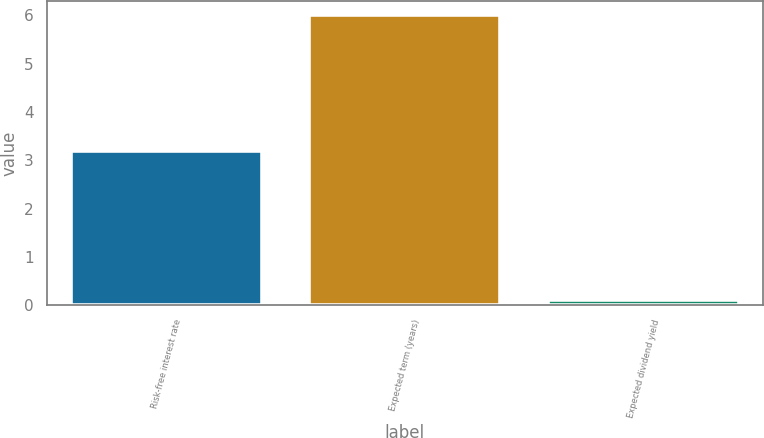Convert chart. <chart><loc_0><loc_0><loc_500><loc_500><bar_chart><fcel>Risk-free interest rate<fcel>Expected term (years)<fcel>Expected dividend yield<nl><fcel>3.2<fcel>6<fcel>0.1<nl></chart> 